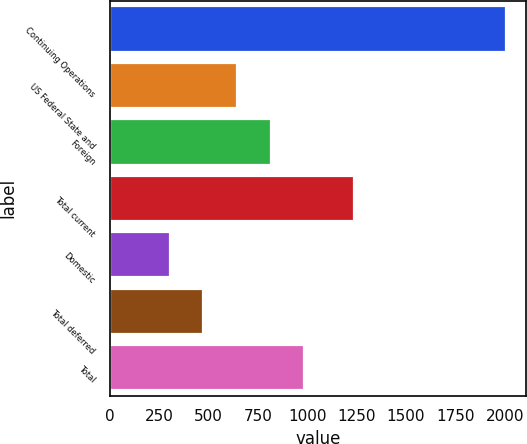<chart> <loc_0><loc_0><loc_500><loc_500><bar_chart><fcel>Continuing Operations<fcel>US Federal State and<fcel>Foreign<fcel>Total current<fcel>Domestic<fcel>Total deferred<fcel>Total<nl><fcel>2007<fcel>644.6<fcel>814.9<fcel>1239<fcel>304<fcel>474.3<fcel>985.2<nl></chart> 